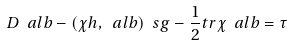<formula> <loc_0><loc_0><loc_500><loc_500>D \ a l b - ( \chi h , \ a l b ) \ s g - \frac { 1 } { 2 } t r \chi \ a l b = \tau</formula> 